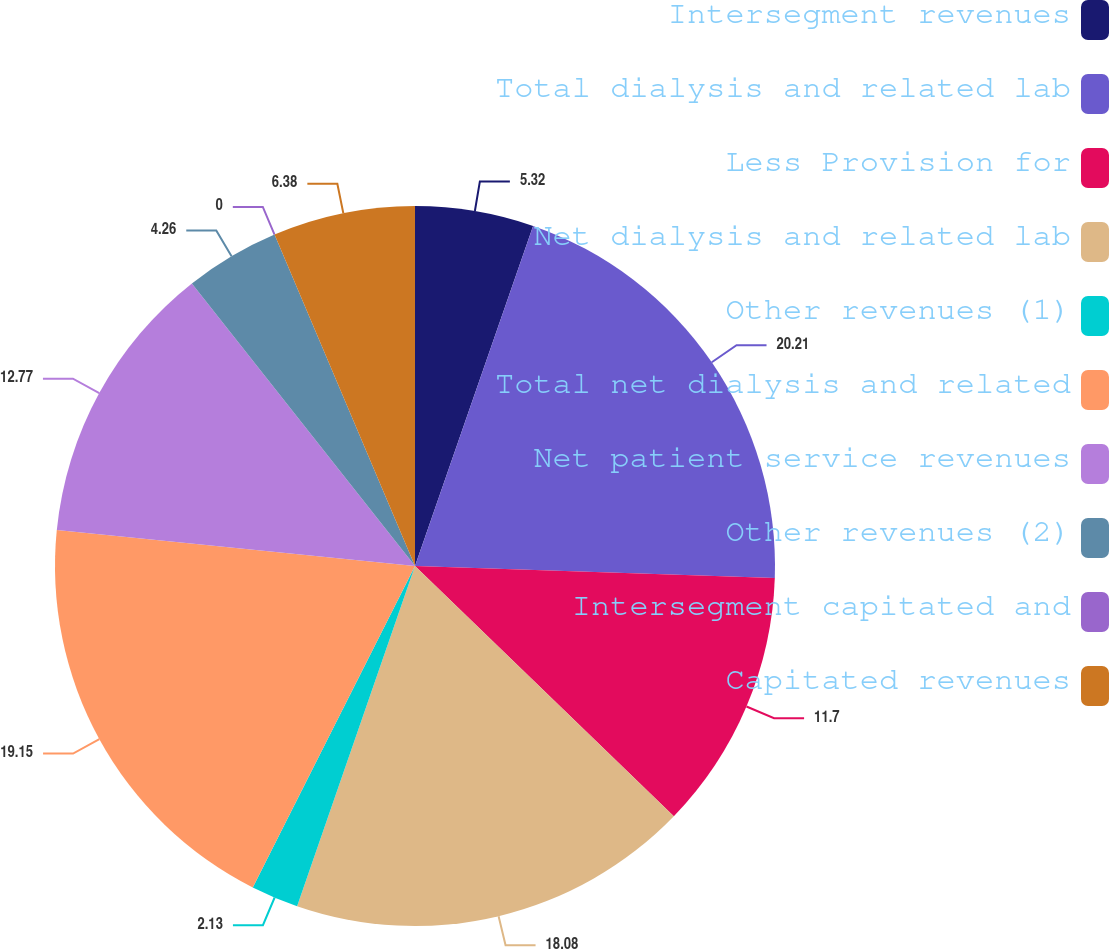<chart> <loc_0><loc_0><loc_500><loc_500><pie_chart><fcel>Intersegment revenues<fcel>Total dialysis and related lab<fcel>Less Provision for<fcel>Net dialysis and related lab<fcel>Other revenues (1)<fcel>Total net dialysis and related<fcel>Net patient service revenues<fcel>Other revenues (2)<fcel>Intersegment capitated and<fcel>Capitated revenues<nl><fcel>5.32%<fcel>20.21%<fcel>11.7%<fcel>18.08%<fcel>2.13%<fcel>19.15%<fcel>12.77%<fcel>4.26%<fcel>0.0%<fcel>6.38%<nl></chart> 